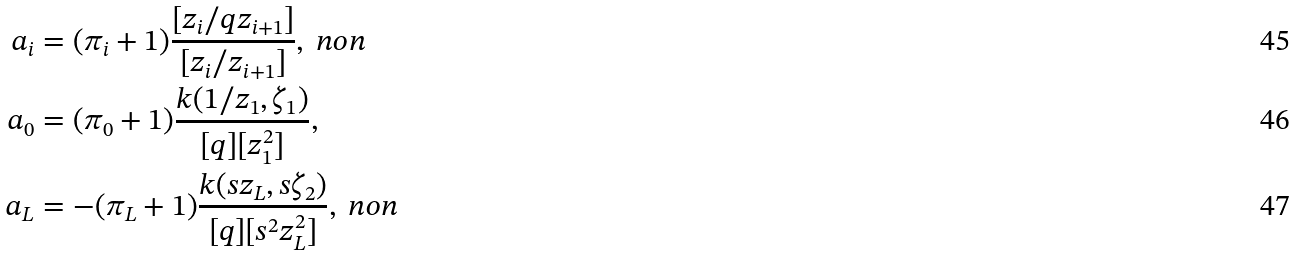Convert formula to latex. <formula><loc_0><loc_0><loc_500><loc_500>a _ { i } & = ( \pi _ { i } + 1 ) \frac { [ z _ { i } / q z _ { i + 1 } ] } { [ z _ { i } / z _ { i + 1 } ] } , \ n o n \\ a _ { 0 } & = ( \pi _ { 0 } + 1 ) \frac { k ( 1 / z _ { 1 } , \zeta _ { 1 } ) } { [ q ] [ z _ { 1 } ^ { 2 } ] } , \\ a _ { L } & = - ( \pi _ { L } + 1 ) \frac { k ( s z _ { L } , s \zeta _ { 2 } ) } { [ q ] [ s ^ { 2 } z _ { L } ^ { 2 } ] } , \ n o n</formula> 